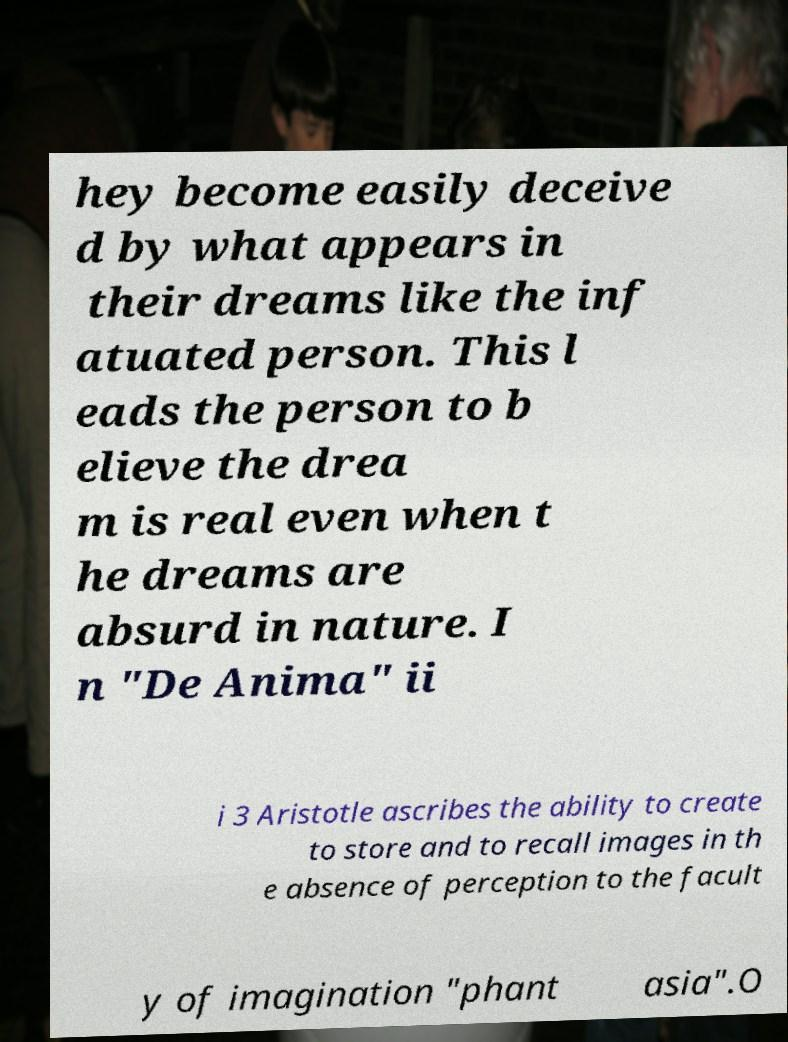For documentation purposes, I need the text within this image transcribed. Could you provide that? hey become easily deceive d by what appears in their dreams like the inf atuated person. This l eads the person to b elieve the drea m is real even when t he dreams are absurd in nature. I n "De Anima" ii i 3 Aristotle ascribes the ability to create to store and to recall images in th e absence of perception to the facult y of imagination "phant asia".O 